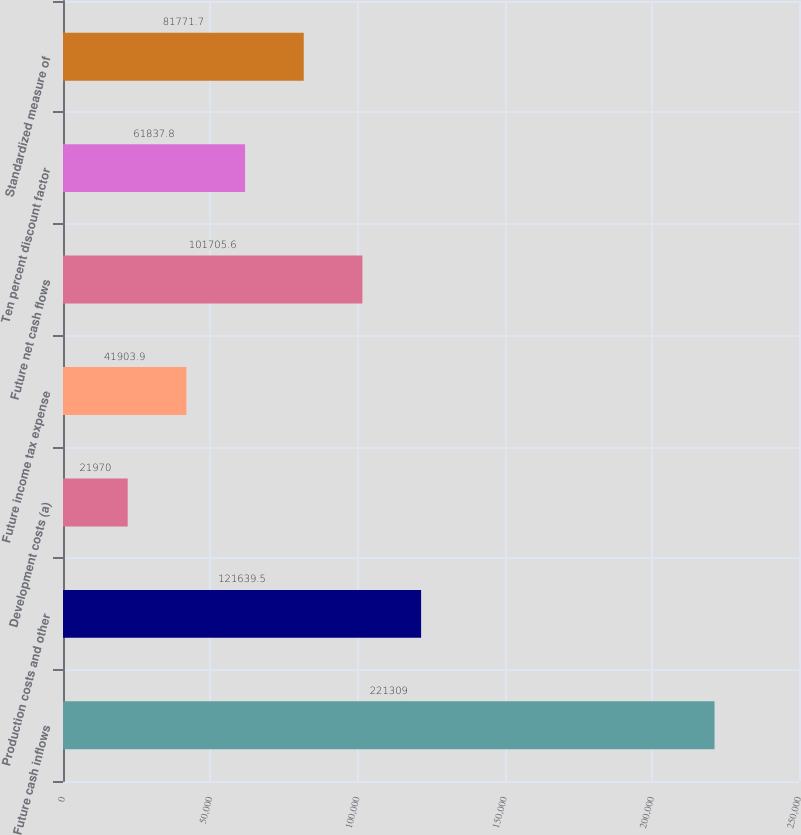Convert chart to OTSL. <chart><loc_0><loc_0><loc_500><loc_500><bar_chart><fcel>Future cash inflows<fcel>Production costs and other<fcel>Development costs (a)<fcel>Future income tax expense<fcel>Future net cash flows<fcel>Ten percent discount factor<fcel>Standardized measure of<nl><fcel>221309<fcel>121640<fcel>21970<fcel>41903.9<fcel>101706<fcel>61837.8<fcel>81771.7<nl></chart> 